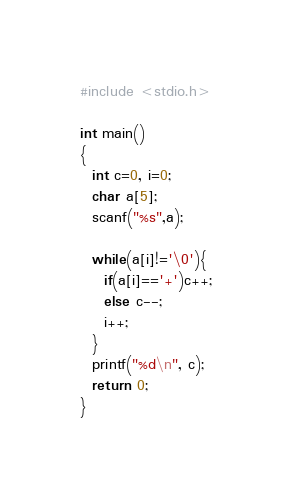<code> <loc_0><loc_0><loc_500><loc_500><_C_>#include <stdio.h>

int main()
{
  int c=0, i=0;
  char a[5];
  scanf("%s",a);

  while(a[i]!='\0'){
    if(a[i]=='+')c++;
    else c--;
    i++;
  }
  printf("%d\n", c);
  return 0;
}
</code> 